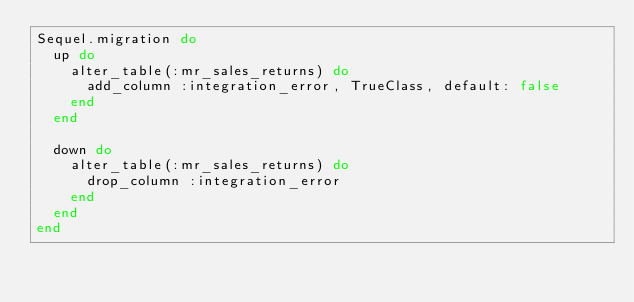<code> <loc_0><loc_0><loc_500><loc_500><_Ruby_>Sequel.migration do
  up do
    alter_table(:mr_sales_returns) do
      add_column :integration_error, TrueClass, default: false
    end
  end

  down do
    alter_table(:mr_sales_returns) do
      drop_column :integration_error
    end
  end
end
</code> 